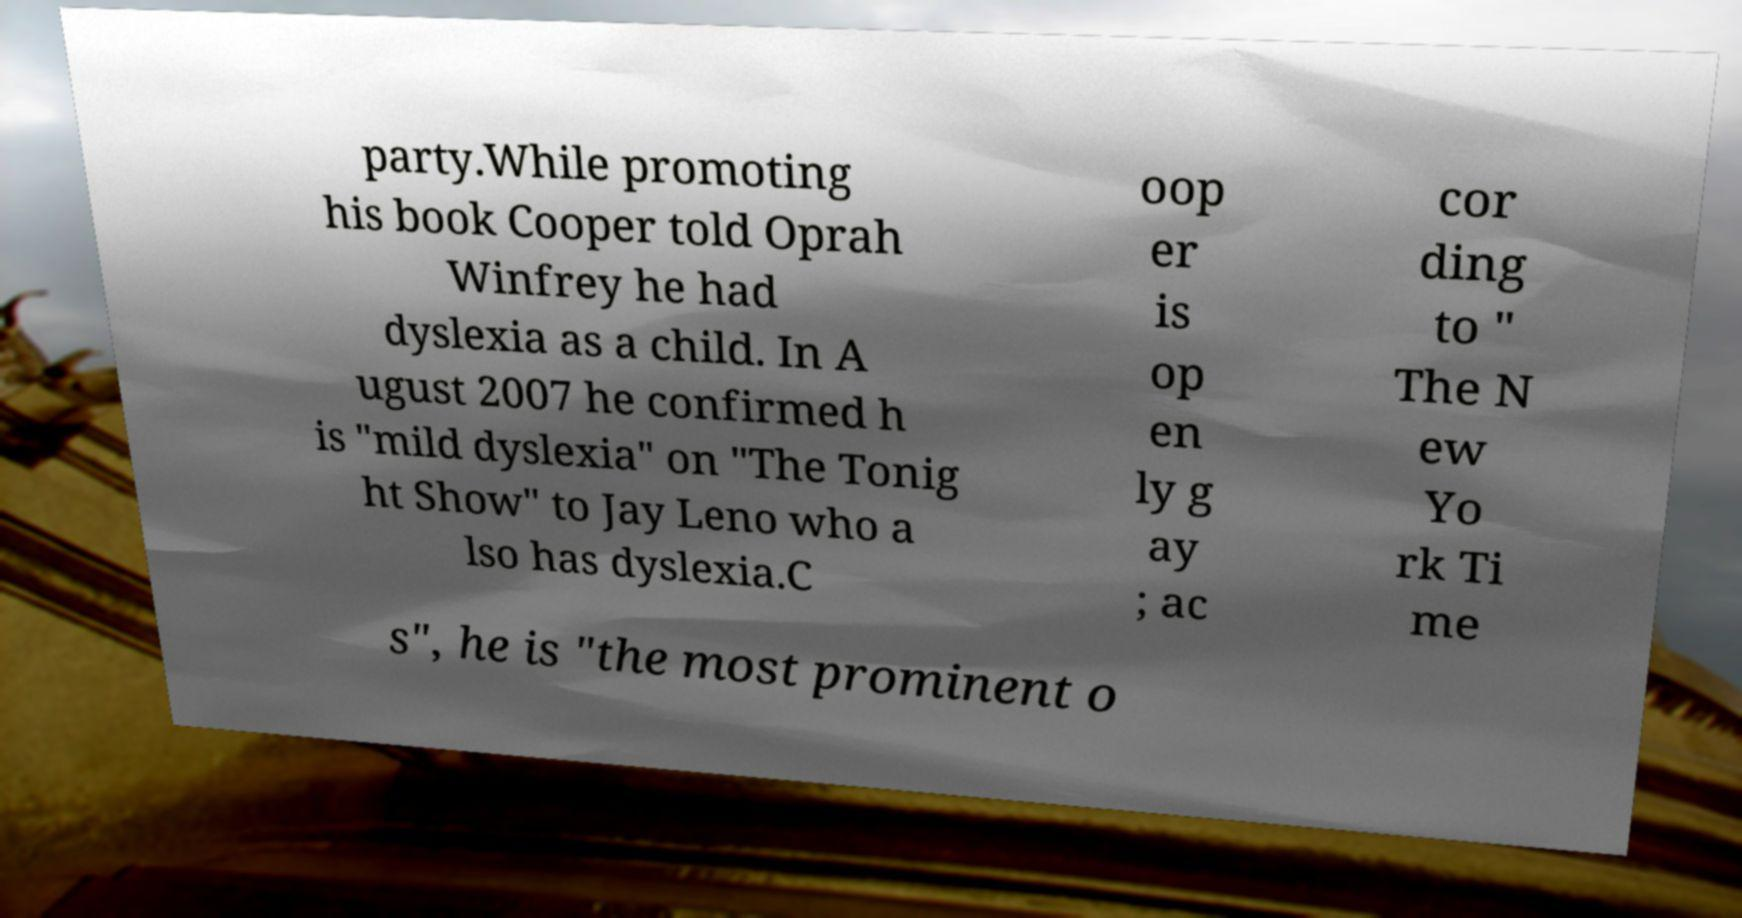Please identify and transcribe the text found in this image. party.While promoting his book Cooper told Oprah Winfrey he had dyslexia as a child. In A ugust 2007 he confirmed h is "mild dyslexia" on "The Tonig ht Show" to Jay Leno who a lso has dyslexia.C oop er is op en ly g ay ; ac cor ding to " The N ew Yo rk Ti me s", he is "the most prominent o 